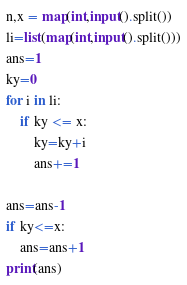<code> <loc_0><loc_0><loc_500><loc_500><_Python_>n,x = map(int,input().split())
li=list(map(int,input().split()))
ans=1
ky=0
for i in li:
    if ky <= x:
        ky=ky+i
        ans+=1

ans=ans-1
if ky<=x:
    ans=ans+1
print(ans)</code> 